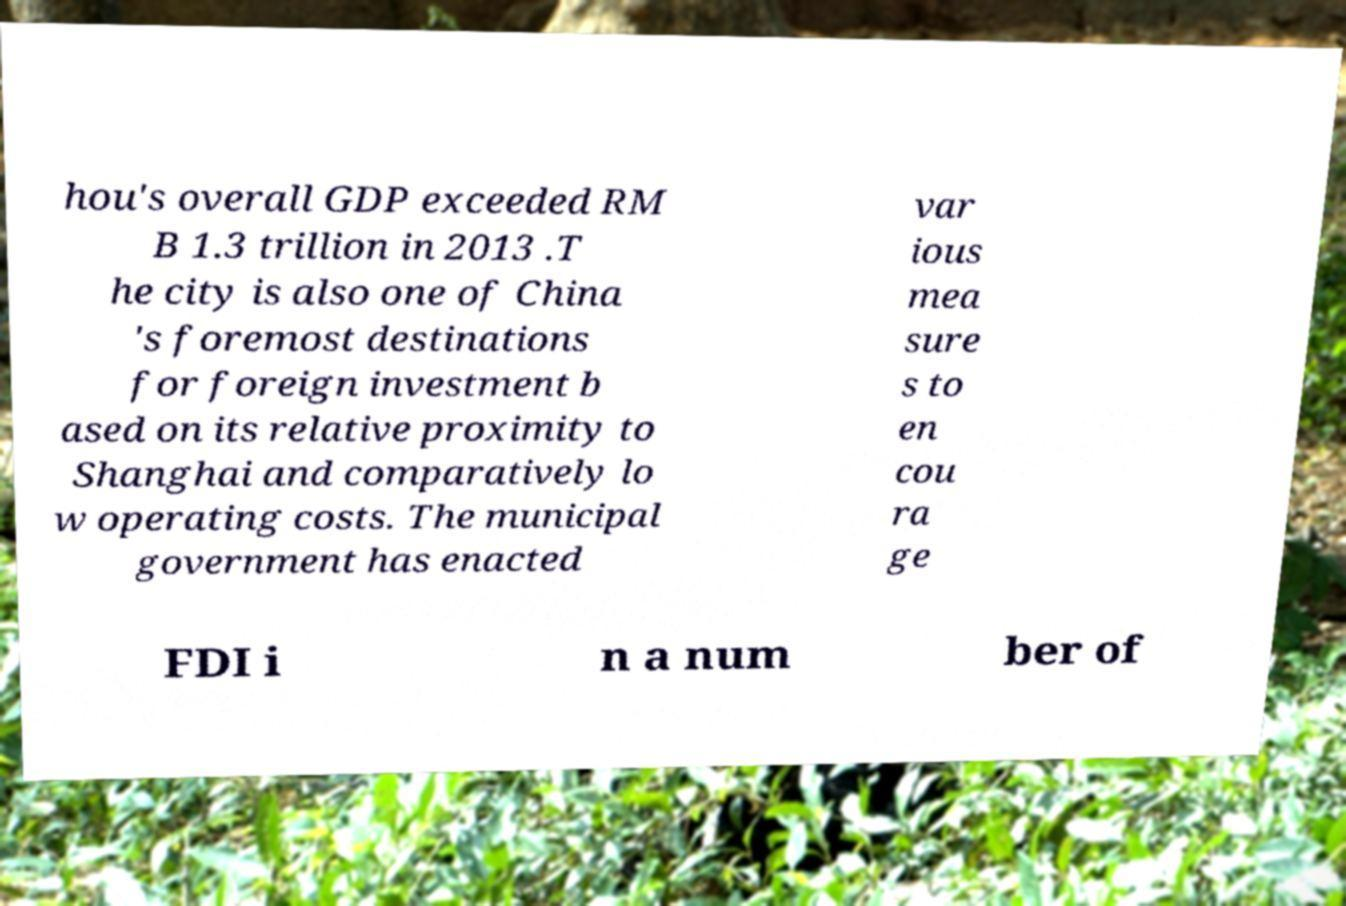Can you accurately transcribe the text from the provided image for me? hou's overall GDP exceeded RM B 1.3 trillion in 2013 .T he city is also one of China 's foremost destinations for foreign investment b ased on its relative proximity to Shanghai and comparatively lo w operating costs. The municipal government has enacted var ious mea sure s to en cou ra ge FDI i n a num ber of 